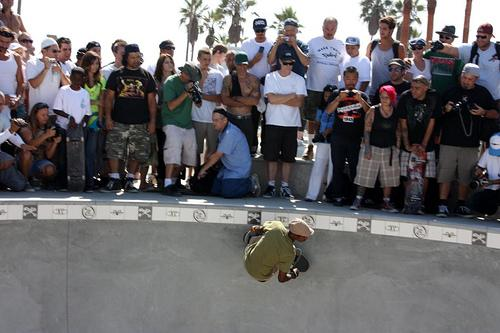What style of skateboarding is this? half pipe 